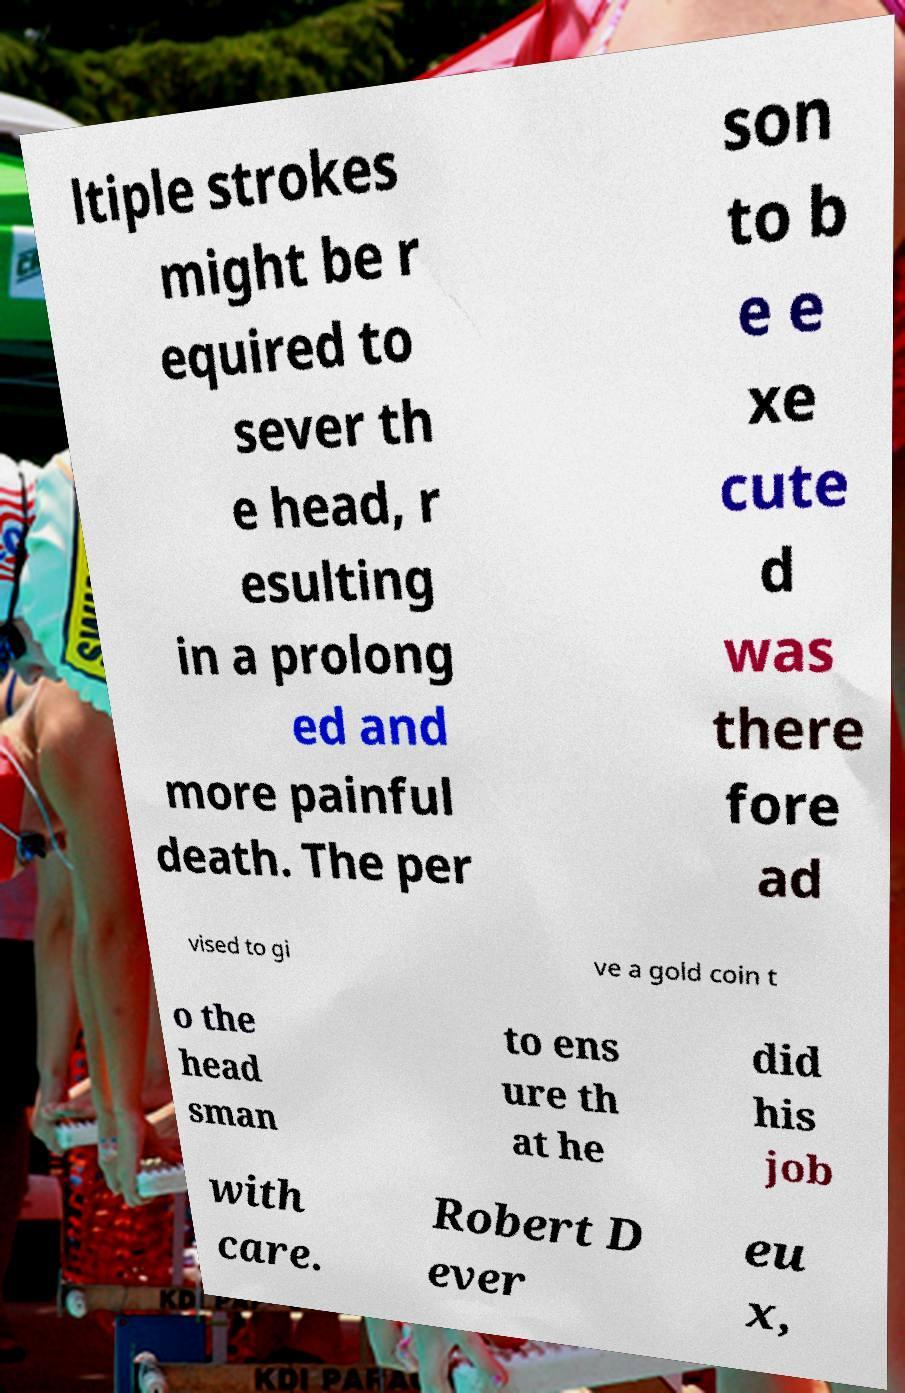Please read and relay the text visible in this image. What does it say? ltiple strokes might be r equired to sever th e head, r esulting in a prolong ed and more painful death. The per son to b e e xe cute d was there fore ad vised to gi ve a gold coin t o the head sman to ens ure th at he did his job with care. Robert D ever eu x, 